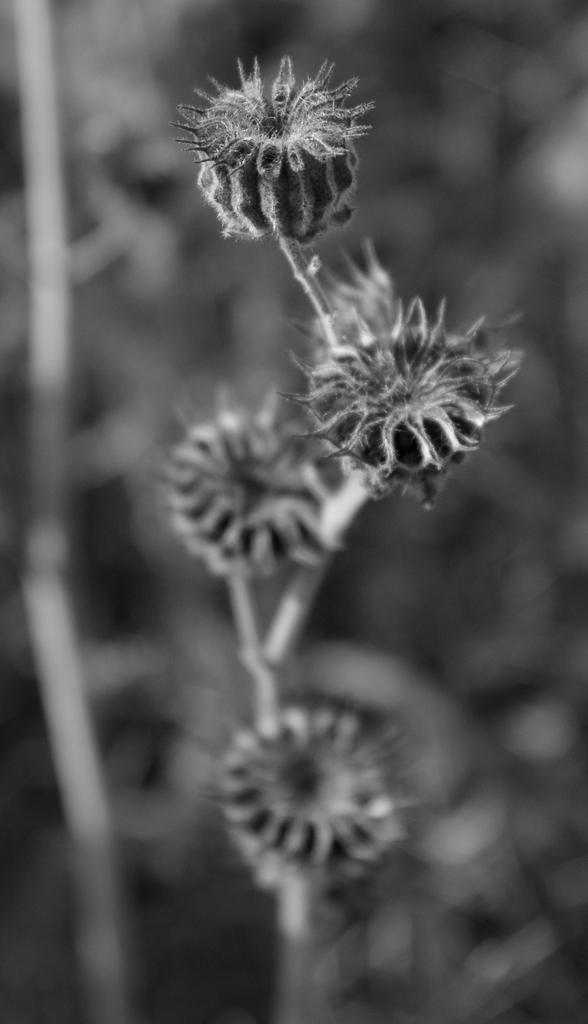What type of plant is visible in the image? There are flowers with stems in the image. Can you describe the background of the image? The background of the image is blurred. What type of arithmetic problem is being solved on the street in the image? There is no arithmetic problem or street present in the image; it features flowers with stems and a blurred background. 